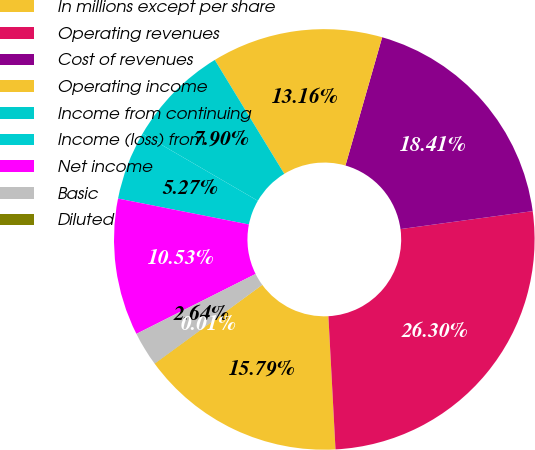Convert chart to OTSL. <chart><loc_0><loc_0><loc_500><loc_500><pie_chart><fcel>In millions except per share<fcel>Operating revenues<fcel>Cost of revenues<fcel>Operating income<fcel>Income from continuing<fcel>Income (loss) from<fcel>Net income<fcel>Basic<fcel>Diluted<nl><fcel>15.79%<fcel>26.31%<fcel>18.42%<fcel>13.16%<fcel>7.9%<fcel>5.27%<fcel>10.53%<fcel>2.64%<fcel>0.01%<nl></chart> 